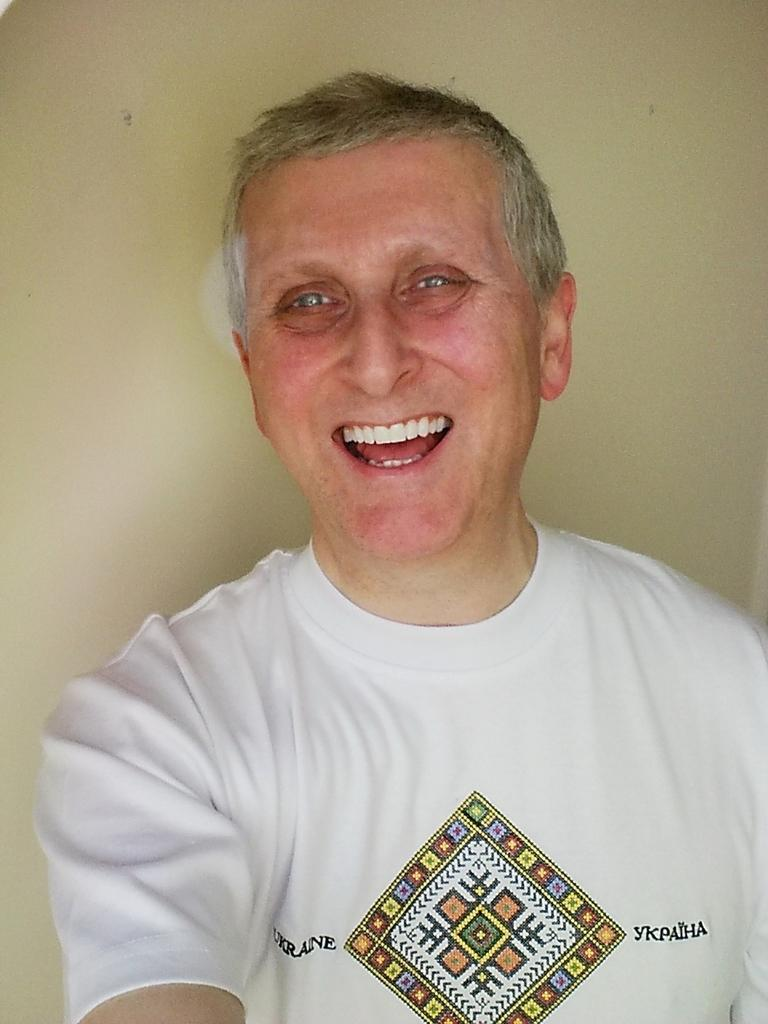Who is in the image? There is a man in the image. What is the man wearing? The man is wearing a white t-shirt. Can you describe the design on the t-shirt? The t-shirt has a design on it. What is written on the t-shirt? There is writing on the t-shirt. How is the man feeling in the image? The man is smiling. What is behind the man in the image? There is a wall behind the man. Can you hear the man laughing in the image? There is no sound in the image, so it is not possible to hear the man laughing. 